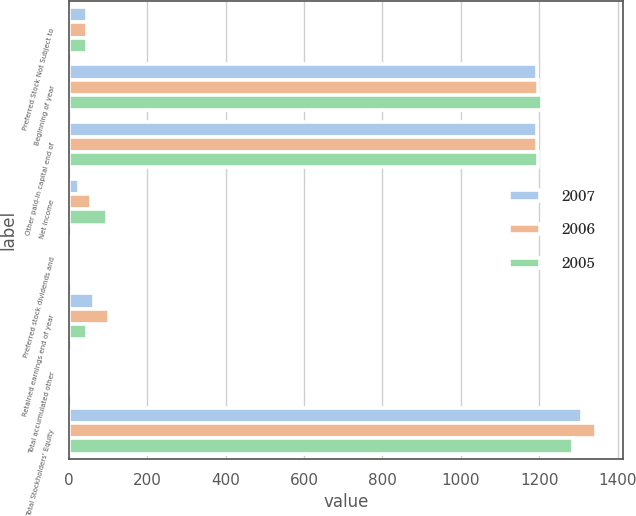Convert chart. <chart><loc_0><loc_0><loc_500><loc_500><stacked_bar_chart><ecel><fcel>Preferred Stock Not Subject to<fcel>Beginning of year<fcel>Other paid-in capital end of<fcel>Net income<fcel>Preferred stock dividends and<fcel>Retained earnings end of year<fcel>Total accumulated other<fcel>Total Stockholders' Equity<nl><fcel>2007<fcel>46<fcel>1194<fcel>1194<fcel>26<fcel>2<fcel>64<fcel>4<fcel>1308<nl><fcel>2006<fcel>46<fcel>1196<fcel>1194<fcel>57<fcel>2<fcel>101<fcel>5<fcel>1346<nl><fcel>2005<fcel>46<fcel>1207<fcel>1196<fcel>97<fcel>2<fcel>46<fcel>1<fcel>1287<nl></chart> 